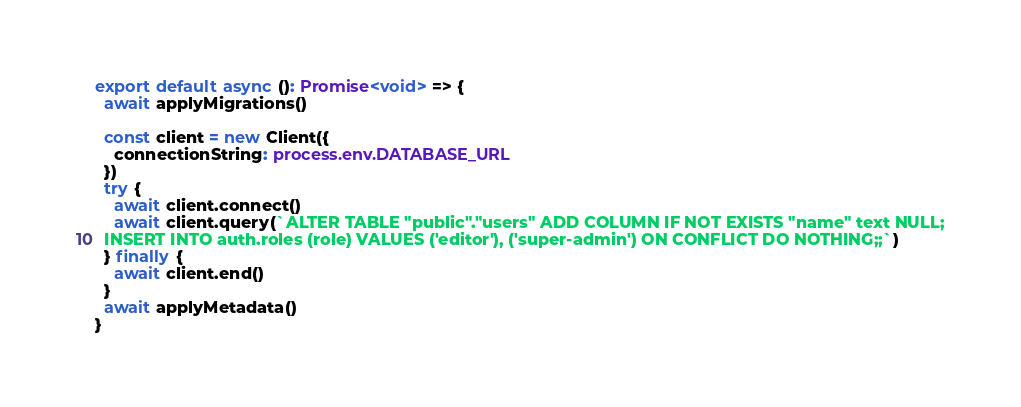Convert code to text. <code><loc_0><loc_0><loc_500><loc_500><_TypeScript_>
export default async (): Promise<void> => {
  await applyMigrations()

  const client = new Client({
    connectionString: process.env.DATABASE_URL
  })
  try {
    await client.connect()
    await client.query(`ALTER TABLE "public"."users" ADD COLUMN IF NOT EXISTS "name" text NULL;
  INSERT INTO auth.roles (role) VALUES ('editor'), ('super-admin') ON CONFLICT DO NOTHING;;`)
  } finally {
    await client.end()
  }
  await applyMetadata()
}
</code> 